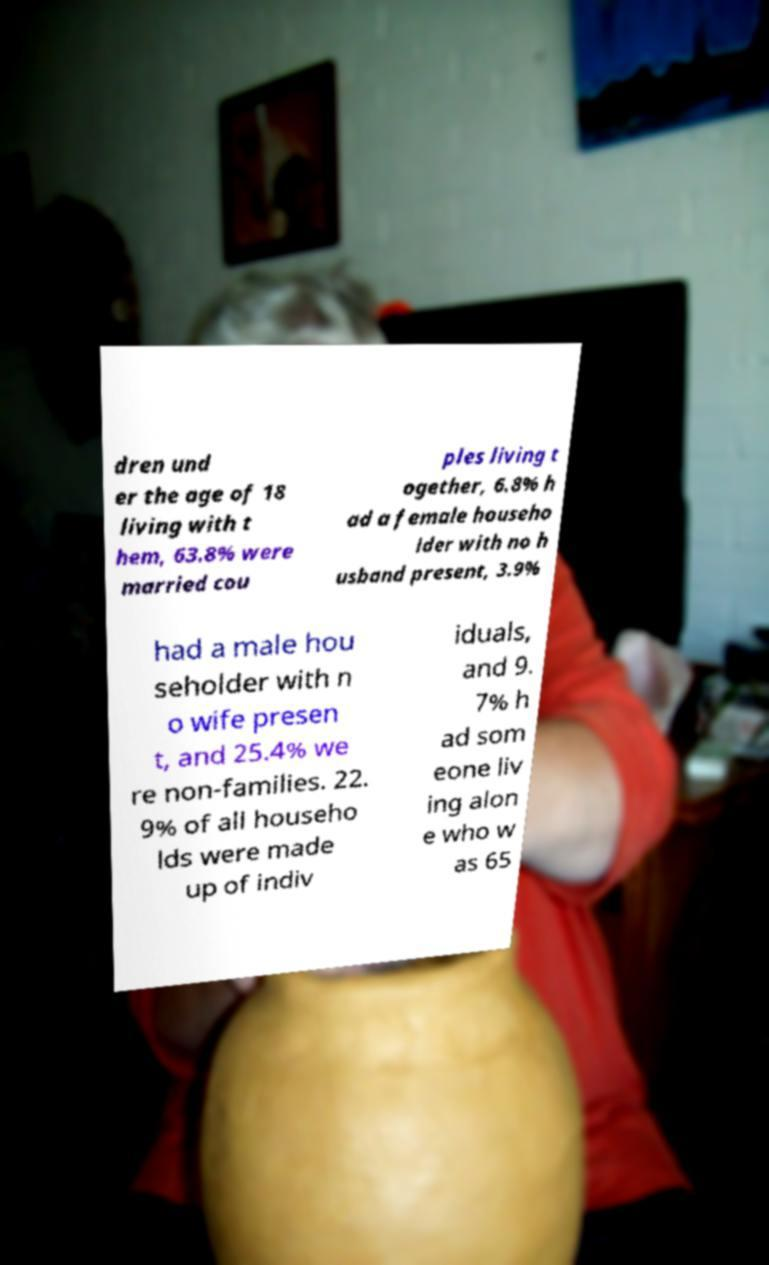There's text embedded in this image that I need extracted. Can you transcribe it verbatim? dren und er the age of 18 living with t hem, 63.8% were married cou ples living t ogether, 6.8% h ad a female househo lder with no h usband present, 3.9% had a male hou seholder with n o wife presen t, and 25.4% we re non-families. 22. 9% of all househo lds were made up of indiv iduals, and 9. 7% h ad som eone liv ing alon e who w as 65 